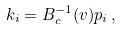Convert formula to latex. <formula><loc_0><loc_0><loc_500><loc_500>k _ { i } = B ^ { - 1 } _ { c } ( v ) p _ { i } \, ,</formula> 